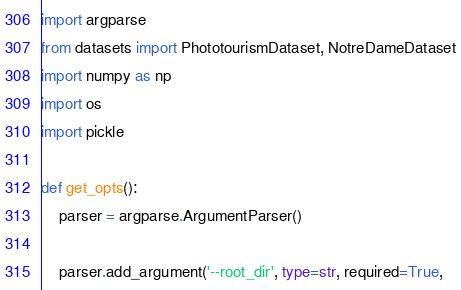<code> <loc_0><loc_0><loc_500><loc_500><_Python_>import argparse
from datasets import PhototourismDataset, NotreDameDataset
import numpy as np
import os
import pickle

def get_opts():
    parser = argparse.ArgumentParser()

    parser.add_argument('--root_dir', type=str, required=True,</code> 